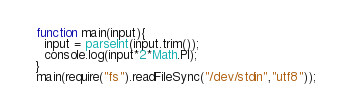Convert code to text. <code><loc_0><loc_0><loc_500><loc_500><_JavaScript_>function main(input){
  input = parseInt(input.trim());
  console.log(input*2*Math.PI);
}
main(require("fs").readFileSync("/dev/stdin","utf8"));</code> 